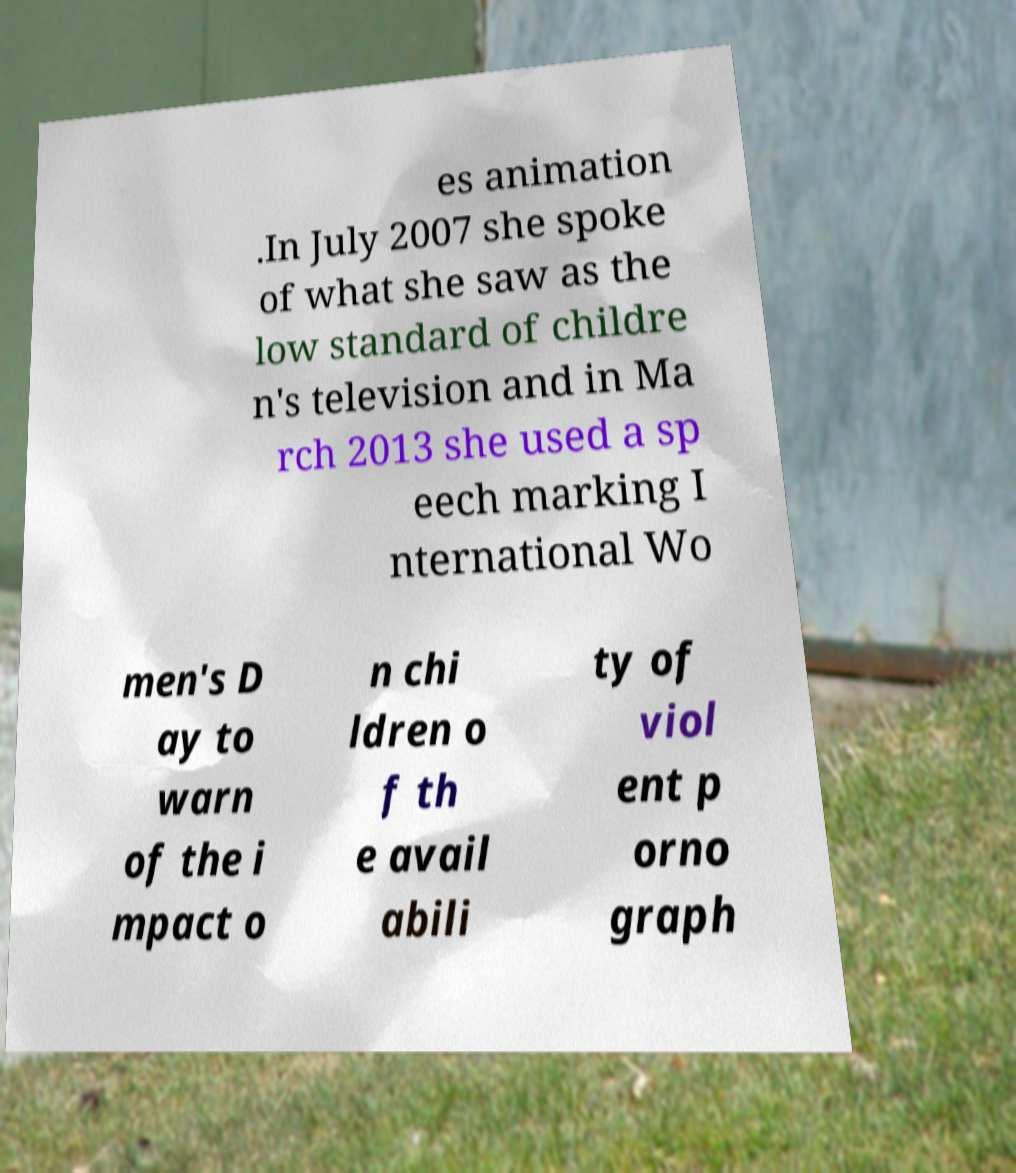Please read and relay the text visible in this image. What does it say? es animation .In July 2007 she spoke of what she saw as the low standard of childre n's television and in Ma rch 2013 she used a sp eech marking I nternational Wo men's D ay to warn of the i mpact o n chi ldren o f th e avail abili ty of viol ent p orno graph 